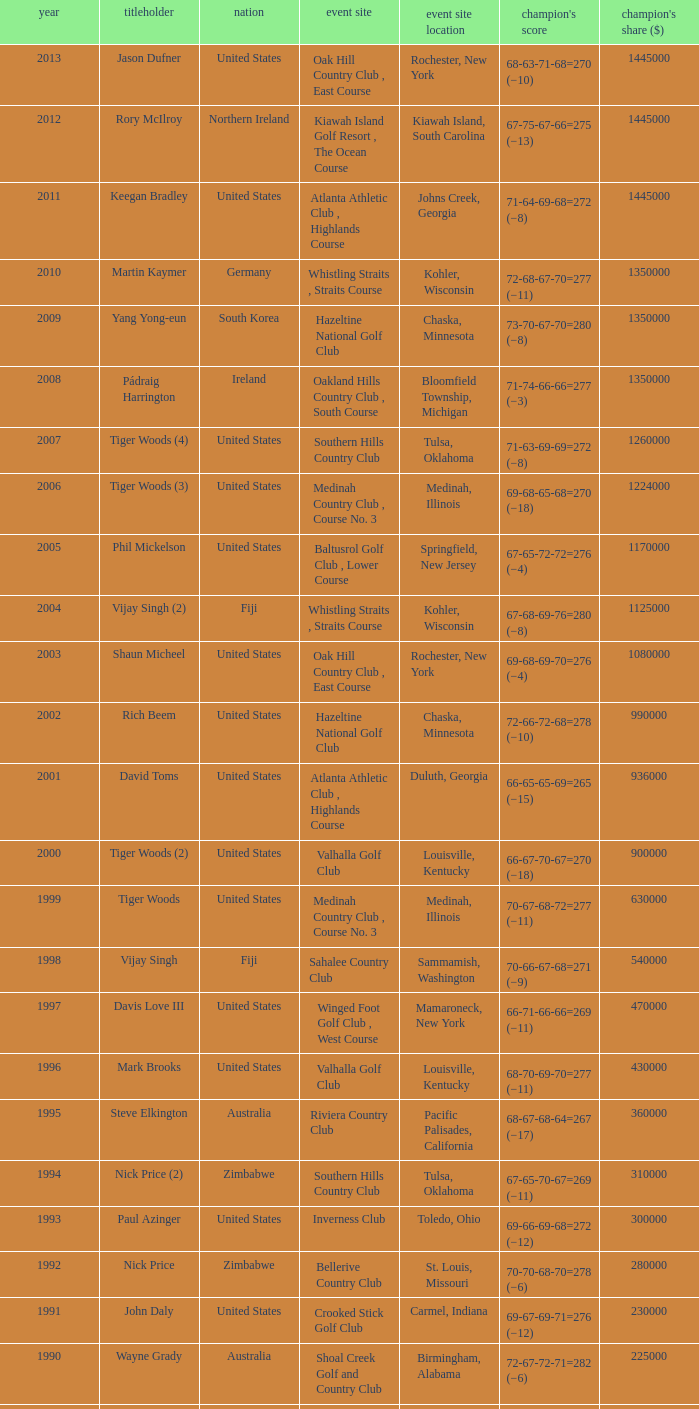Where is the Bellerive Country Club venue located? St. Louis, Missouri. 